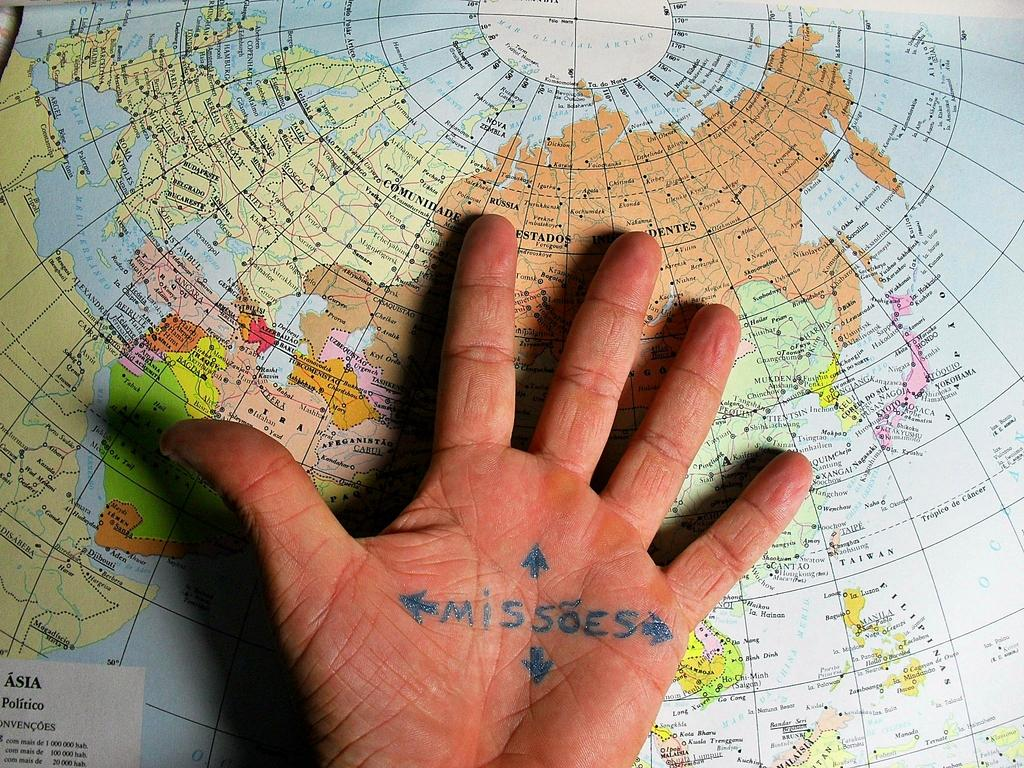What part of a person's body is visible in the image? There is a person's hand in the image. What is written on the hand palm? There is text written on the hand palm. What is located below the person's hand in the image? There is a map below the person's hand in the image. What type of paint is being used to adjust the purpose of the map in the image? There is no paint, adjustment, or purpose mentioned in the image; it only shows a person's hand with text on the palm and a map below it. 